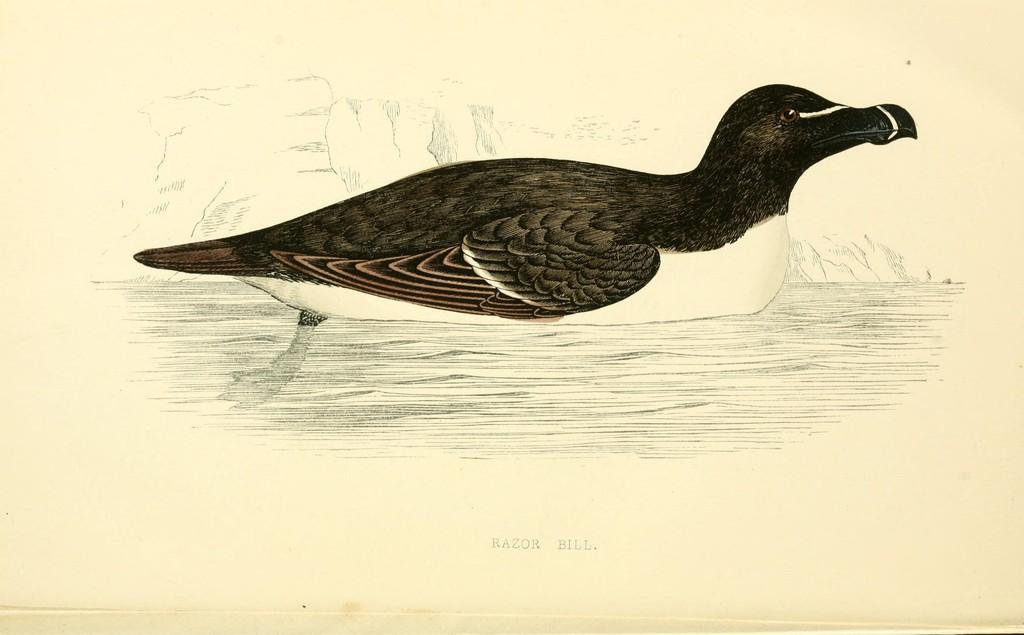What animal is in the water in the image? There is a duck in the water in the image. What can be found at the bottom of the image? There is text at the bottom of the image. What type of image is this? The image appears to be a piece of art. What type of plants can be seen growing near the gate in the image? There is no gate or plants present in the image; it features a duck in the water and text at the bottom. 